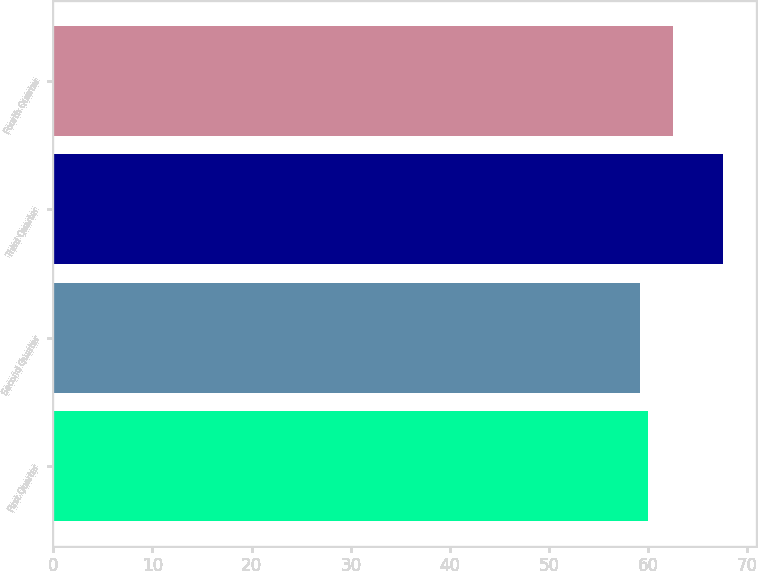Convert chart to OTSL. <chart><loc_0><loc_0><loc_500><loc_500><bar_chart><fcel>First Quarter<fcel>Second Quarter<fcel>Third Quarter<fcel>Fourth Quarter<nl><fcel>59.98<fcel>59.14<fcel>67.5<fcel>62.53<nl></chart> 